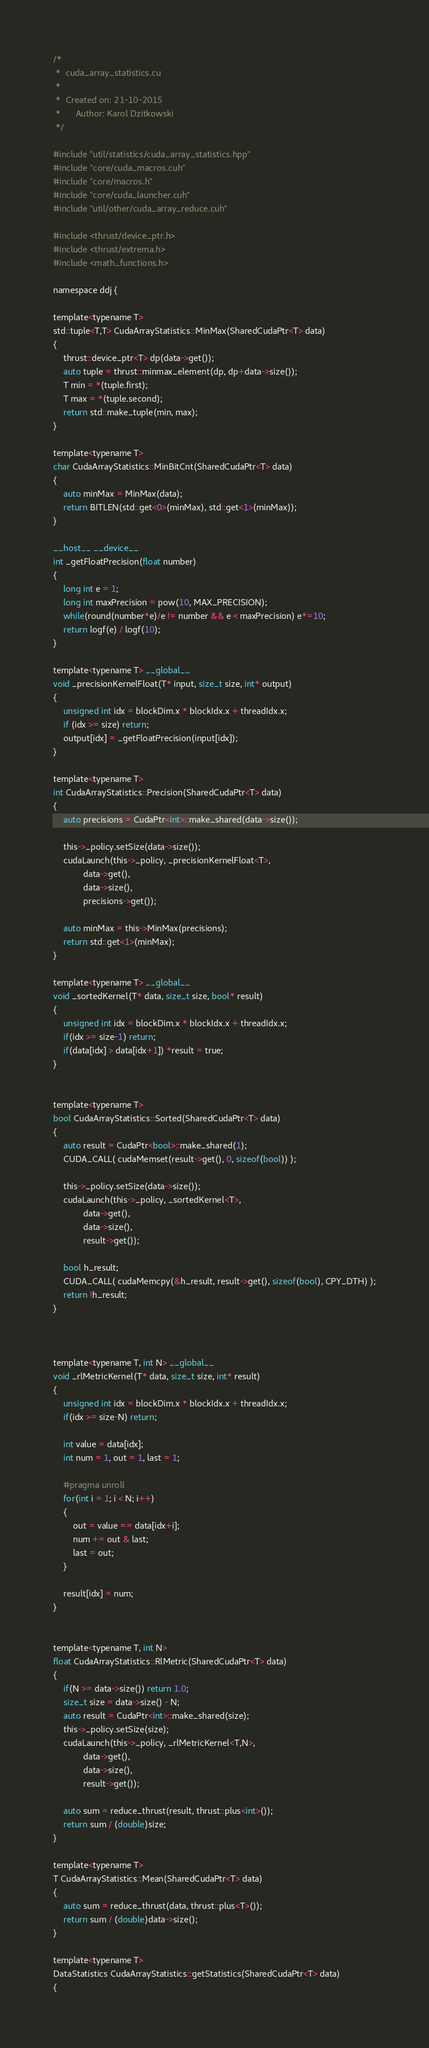<code> <loc_0><loc_0><loc_500><loc_500><_Cuda_>/*
 *  cuda_array_statistics.cu
 *
 *  Created on: 21-10-2015
 *      Author: Karol Dzitkowski
 */

#include "util/statistics/cuda_array_statistics.hpp"
#include "core/cuda_macros.cuh"
#include "core/macros.h"
#include "core/cuda_launcher.cuh"
#include "util/other/cuda_array_reduce.cuh"

#include <thrust/device_ptr.h>
#include <thrust/extrema.h>
#include <math_functions.h>

namespace ddj {

template<typename T>
std::tuple<T,T> CudaArrayStatistics::MinMax(SharedCudaPtr<T> data)
{
	thrust::device_ptr<T> dp(data->get());
	auto tuple = thrust::minmax_element(dp, dp+data->size());
	T min = *(tuple.first);
	T max = *(tuple.second);
	return std::make_tuple(min, max);
}

template<typename T>
char CudaArrayStatistics::MinBitCnt(SharedCudaPtr<T> data)
{
	auto minMax = MinMax(data);
	return BITLEN(std::get<0>(minMax), std::get<1>(minMax));
}

__host__ __device__
int _getFloatPrecision(float number)
{
	long int e = 1;
	long int maxPrecision = pow(10, MAX_PRECISION);
	while(round(number*e)/e != number && e < maxPrecision) e*=10;
	return logf(e) / logf(10);
}

template<typename T> __global__
void _precisionKernelFloat(T* input, size_t size, int* output)
{
	unsigned int idx = blockDim.x * blockIdx.x + threadIdx.x;
	if (idx >= size) return;
	output[idx] = _getFloatPrecision(input[idx]);
}

template<typename T>
int CudaArrayStatistics::Precision(SharedCudaPtr<T> data)
{
	auto precisions = CudaPtr<int>::make_shared(data->size());

	this->_policy.setSize(data->size());
	cudaLaunch(this->_policy, _precisionKernelFloat<T>,
			data->get(),
			data->size(),
			precisions->get());

	auto minMax = this->MinMax(precisions);
	return std::get<1>(minMax);
}

template<typename T> __global__
void _sortedKernel(T* data, size_t size, bool* result)
{
	unsigned int idx = blockDim.x * blockIdx.x + threadIdx.x;
	if(idx >= size-1) return;
	if(data[idx] > data[idx+1]) *result = true;
}


template<typename T>
bool CudaArrayStatistics::Sorted(SharedCudaPtr<T> data)
{
	auto result = CudaPtr<bool>::make_shared(1);
	CUDA_CALL( cudaMemset(result->get(), 0, sizeof(bool)) );

	this->_policy.setSize(data->size());
	cudaLaunch(this->_policy, _sortedKernel<T>,
			data->get(),
			data->size(),
			result->get());

	bool h_result;
	CUDA_CALL( cudaMemcpy(&h_result, result->get(), sizeof(bool), CPY_DTH) );
	return !h_result;
}



template<typename T, int N> __global__
void _rlMetricKernel(T* data, size_t size, int* result)
{
	unsigned int idx = blockDim.x * blockIdx.x + threadIdx.x;
	if(idx >= size-N) return;

	int value = data[idx];
	int num = 1, out = 1, last = 1;

	#pragma unroll
	for(int i = 1; i < N; i++)
	{
		out = value == data[idx+i];
		num += out & last;
		last = out;
	}

	result[idx] = num;
}


template<typename T, int N>
float CudaArrayStatistics::RlMetric(SharedCudaPtr<T> data)
{
	if(N >= data->size()) return 1.0;
	size_t size = data->size() - N;
	auto result = CudaPtr<int>::make_shared(size);
	this->_policy.setSize(size);
	cudaLaunch(this->_policy, _rlMetricKernel<T,N>,
			data->get(),
			data->size(),
			result->get());

	auto sum = reduce_thrust(result, thrust::plus<int>());
	return sum / (double)size;
}

template<typename T>
T CudaArrayStatistics::Mean(SharedCudaPtr<T> data)
{
	auto sum = reduce_thrust(data, thrust::plus<T>());
	return sum / (double)data->size();
}

template<typename T>
DataStatistics CudaArrayStatistics::getStatistics(SharedCudaPtr<T> data)
{</code> 